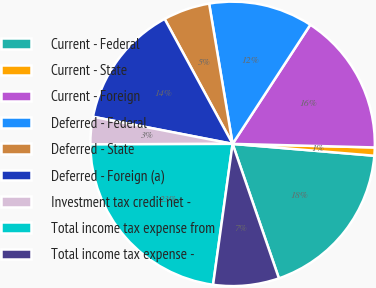Convert chart. <chart><loc_0><loc_0><loc_500><loc_500><pie_chart><fcel>Current - Federal<fcel>Current - State<fcel>Current - Foreign<fcel>Deferred - Federal<fcel>Deferred - State<fcel>Deferred - Foreign (a)<fcel>Investment tax credit net -<fcel>Total income tax expense from<fcel>Total income tax expense -<nl><fcel>18.39%<fcel>0.93%<fcel>16.2%<fcel>11.84%<fcel>5.29%<fcel>14.02%<fcel>3.11%<fcel>22.75%<fcel>7.47%<nl></chart> 